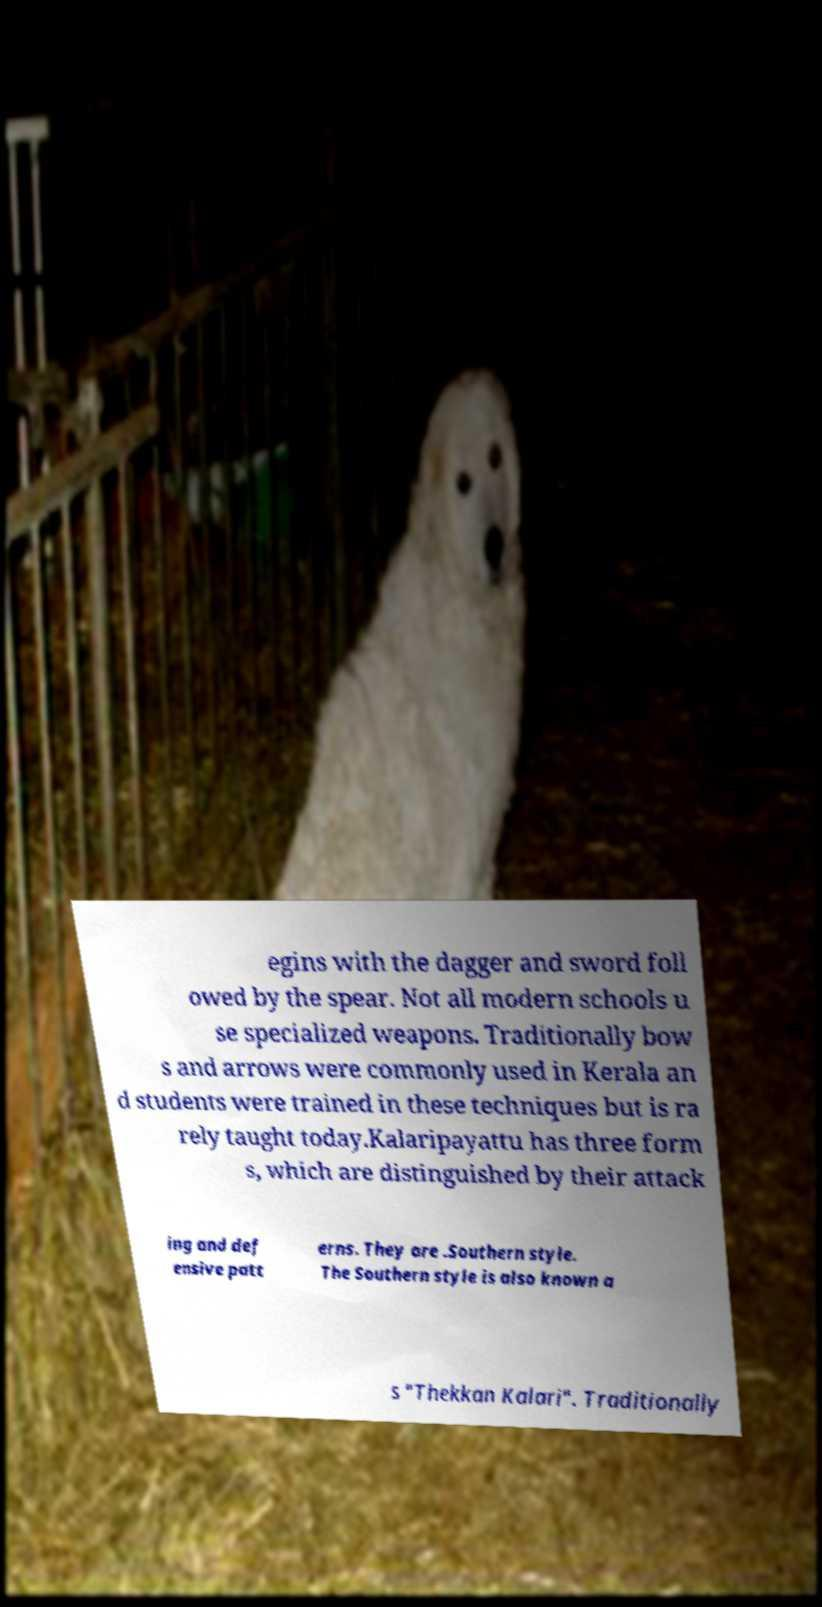Please read and relay the text visible in this image. What does it say? egins with the dagger and sword foll owed by the spear. Not all modern schools u se specialized weapons. Traditionally bow s and arrows were commonly used in Kerala an d students were trained in these techniques but is ra rely taught today.Kalaripayattu has three form s, which are distinguished by their attack ing and def ensive patt erns. They are .Southern style. The Southern style is also known a s "Thekkan Kalari". Traditionally 